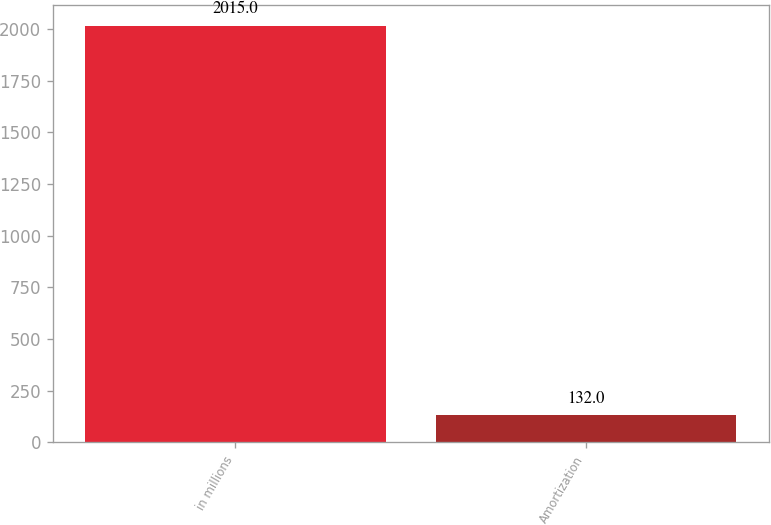Convert chart to OTSL. <chart><loc_0><loc_0><loc_500><loc_500><bar_chart><fcel>in millions<fcel>Amortization<nl><fcel>2015<fcel>132<nl></chart> 